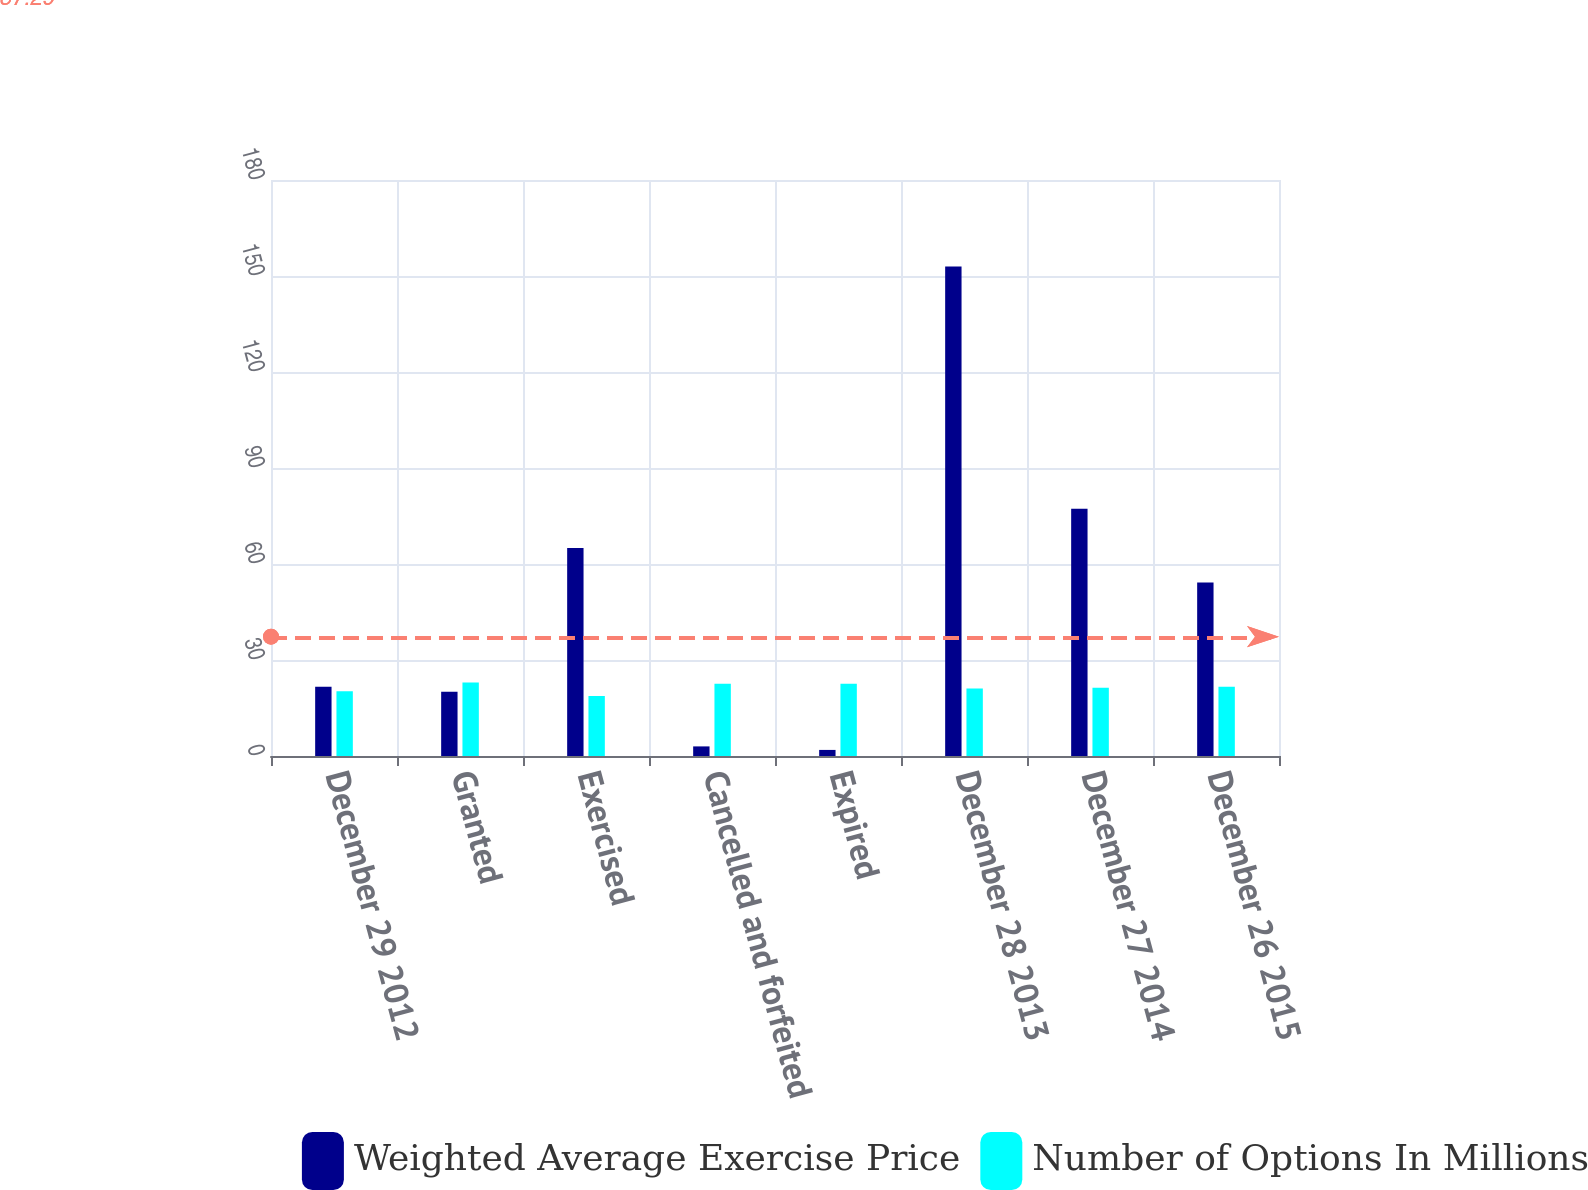Convert chart. <chart><loc_0><loc_0><loc_500><loc_500><stacked_bar_chart><ecel><fcel>December 29 2012<fcel>Granted<fcel>Exercised<fcel>Cancelled and forfeited<fcel>Expired<fcel>December 28 2013<fcel>December 27 2014<fcel>December 26 2015<nl><fcel>Weighted Average Exercise Price<fcel>21.65<fcel>20.1<fcel>65<fcel>3<fcel>1.9<fcel>153<fcel>77.3<fcel>54.2<nl><fcel>Number of Options In Millions<fcel>20.2<fcel>22.99<fcel>18.76<fcel>22.58<fcel>22.56<fcel>21.1<fcel>21.3<fcel>21.65<nl></chart> 